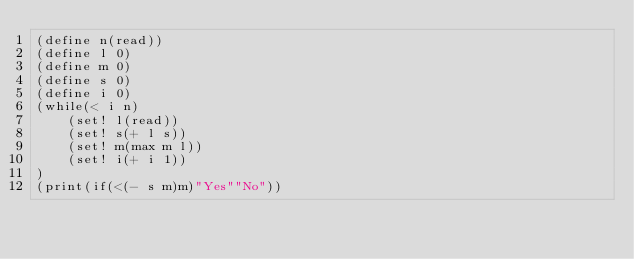<code> <loc_0><loc_0><loc_500><loc_500><_Scheme_>(define n(read))
(define l 0)
(define m 0)
(define s 0)
(define i 0)
(while(< i n)
	(set! l(read))
	(set! s(+ l s))
	(set! m(max m l))
	(set! i(+ i 1))
)
(print(if(<(- s m)m)"Yes""No"))</code> 